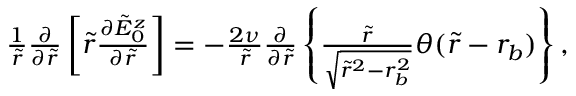<formula> <loc_0><loc_0><loc_500><loc_500>\begin{array} { r } { \frac { 1 } { \tilde { r } } \frac { \partial } { \partial \tilde { r } } \left [ \tilde { r } \frac { \partial \tilde { E } _ { 0 } ^ { z } } { \partial \tilde { r } } \right ] = - \frac { 2 \nu } { \tilde { r } } \frac { \partial } { \partial \tilde { r } } \left \{ \frac { \tilde { r } } { \sqrt { \tilde { r } ^ { 2 } - r _ { b } ^ { 2 } } } \theta ( \tilde { r } - r _ { b } ) \right \} , } \end{array}</formula> 